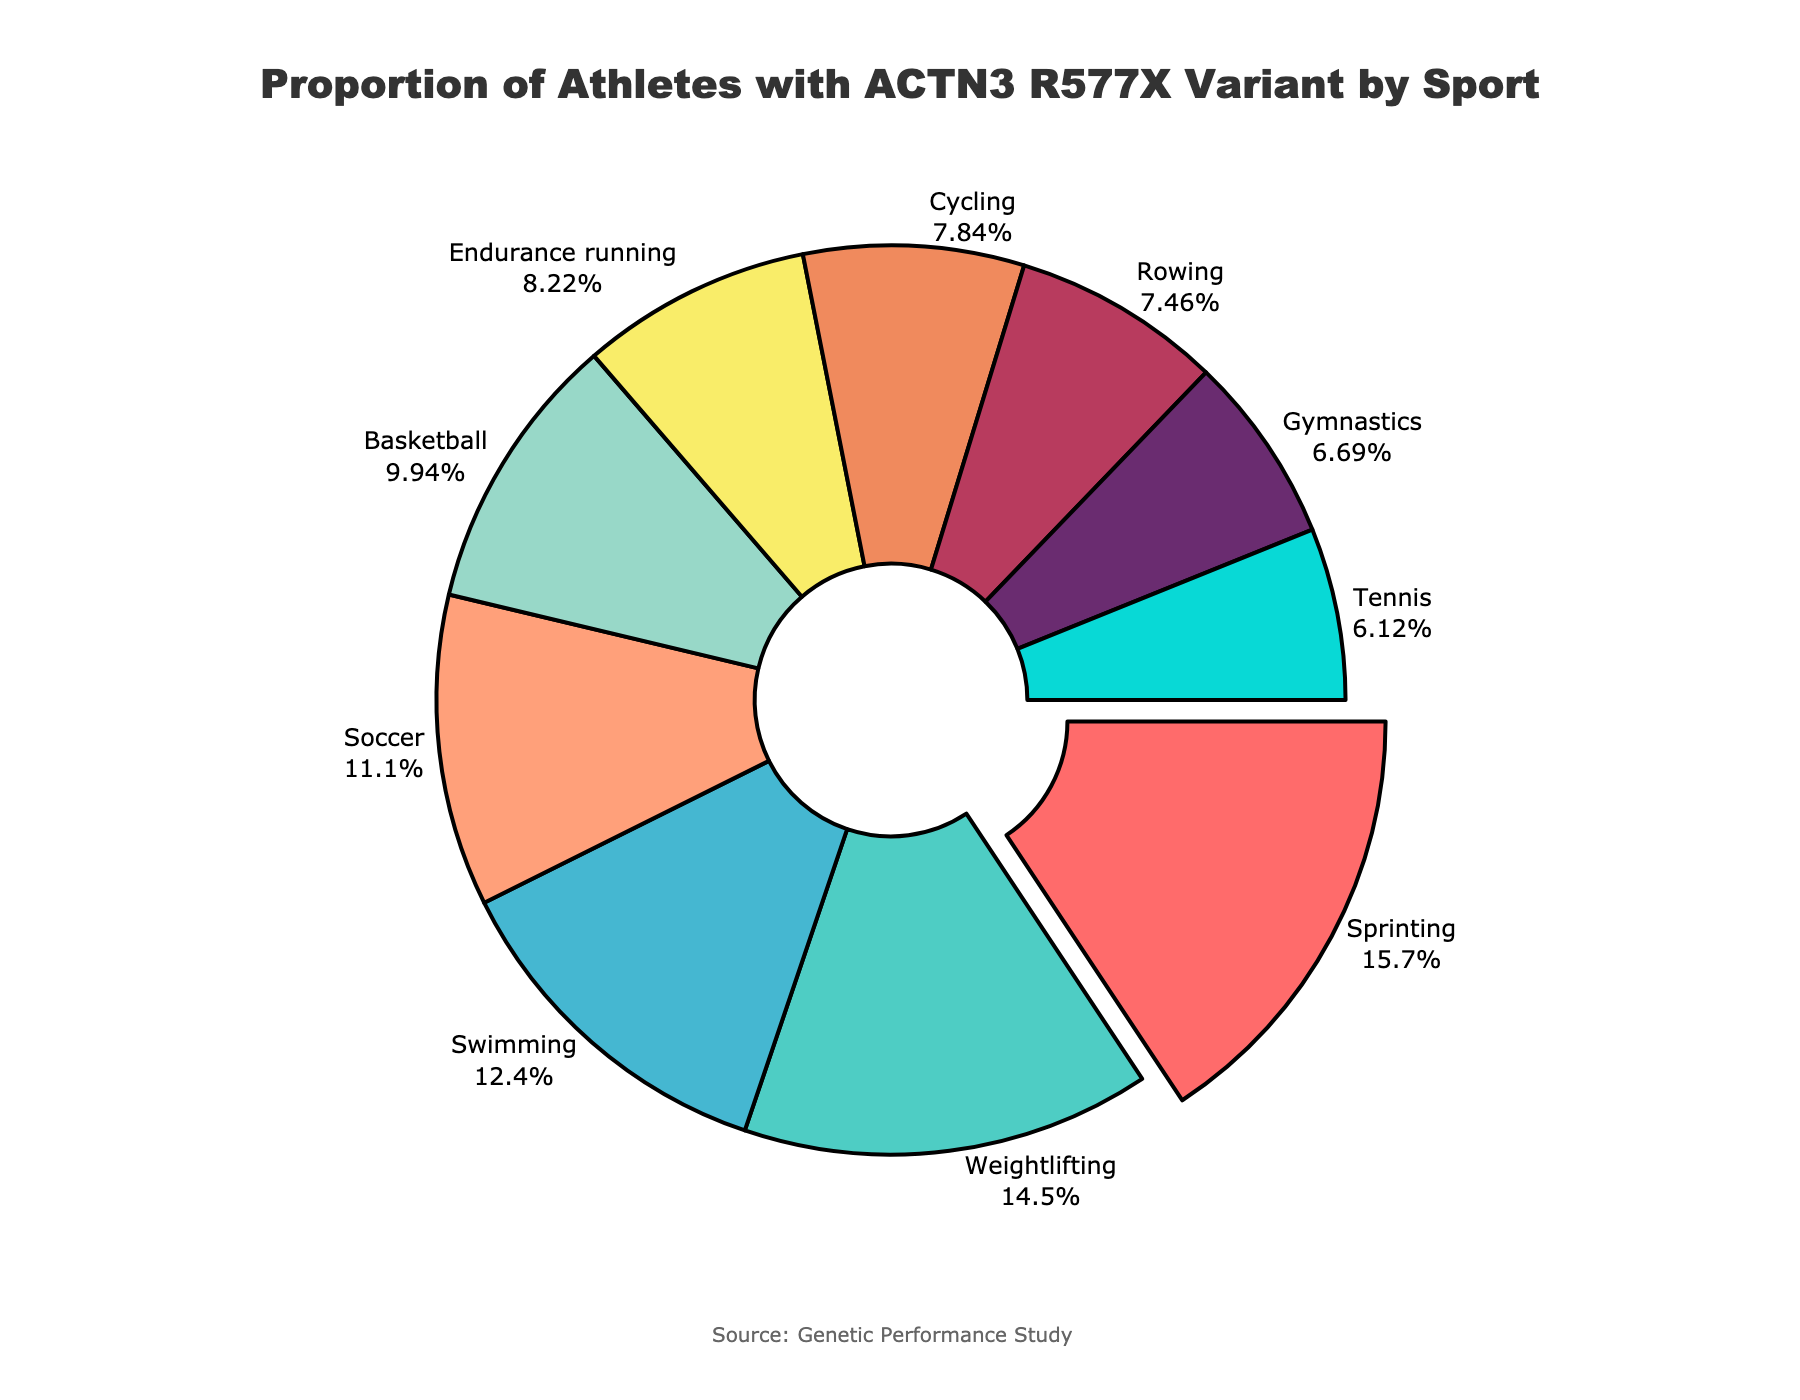What sport has the highest proportion of athletes with the ACTN3 R577X variant? Identify the segment with the largest proportion. Sprinting has the largest percentage at 82%.
Answer: Sprinting Which sports have a proportion of athletes with the ACTN3 R577X variant below 50%? Identify segments with percentages less than 50%. The sports listed as Basketball, Endurance running, Cycling, Rowing, Gymnastics, and Tennis fall into this category.
Answer: Basketball, Endurance running, Cycling, Rowing, Gymnastics, Tennis What is the combined percentage of athletes with the ACTN3 R577X variant in Swimming and Soccer? Sum the percentages of Swimming (65%) and Soccer (58%).
Answer: 123% Which sport has a slightly higher percentage of the ACTN3 R577X variant, Basketball or Soccer? Compare the percentages of Basketball (52%) and Soccer (58%). Soccer has a higher percentage.
Answer: Soccer What is the difference in the proportion of athletes with the ACTN3 R577X variant between Sprinting and Gymnastics? Subtract the percentage of Gymnastics (35%) from Sprinting (82%).
Answer: 47% Which sport segment is marked by the color blue? Identify the sports corresponding to blue by visually inspecting the chart. The blue color is associated with the Swimming segment.
Answer: Swimming Which sport is represented by the smallest segment in the chart? Identify the smallest visual segment, which corresponds to the least percentage. Tennis has the smallest segment at 32%.
Answer: Tennis Is there a larger proportion of athletes with the ACTN3 R577X variant in Weightlifting or Cycling? Compare the percentages of Weightlifting (76%) and Cycling (41%). Weightlifting has a larger proportion.
Answer: Weightlifting What is the proportion difference between the sport with the highest proportion and the sport with the lowest proportion of athletes with the ACTN3 R577X variant? Subtract the smallest percentage (Tennis 32%) from the largest percentage (Sprinting 82%).
Answer: 50% Which sports have a proportion of athletes with the ACTN3 R577X variant close to the median value in the data? Calculate the median percentage. The sorted percentages are: 32%, 35%, 39%, 41%, 43%, 52%, 58%, 65%, 76%, 82%. The median value is the average of 43% and 52%, so 47.5%. Sports close to this value are Endurance running (43%) and Basketball (52%).
Answer: Endurance running, Basketball 